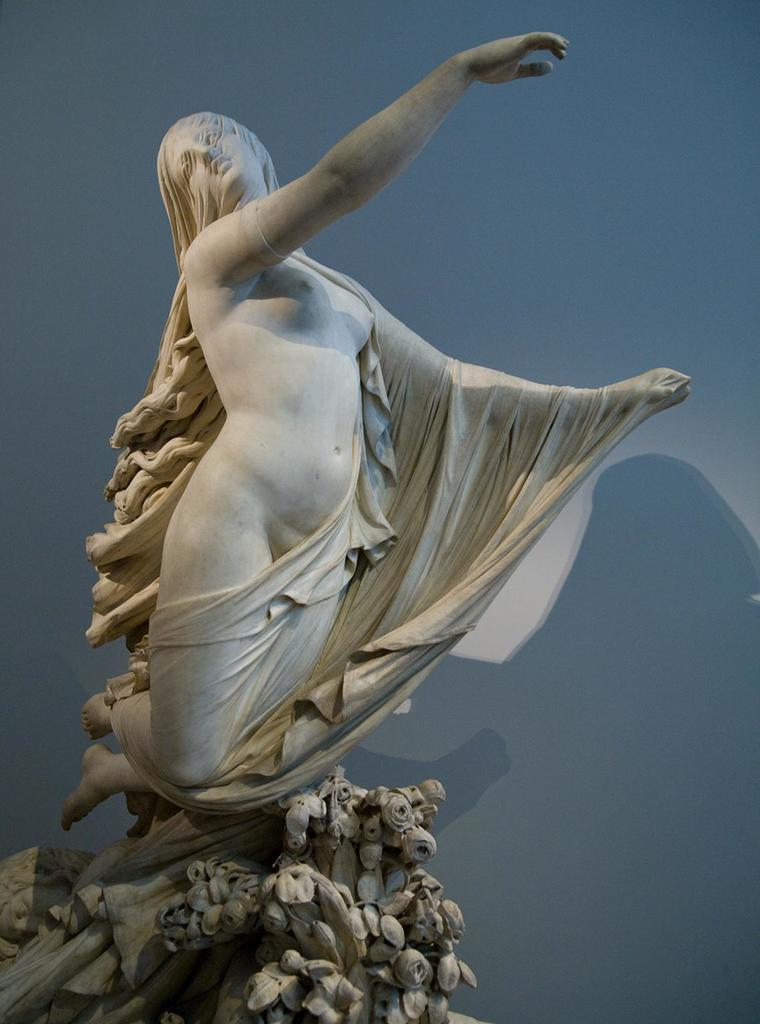What is the main subject in the foreground of the image? There is a sculpture in the foreground of the image. What can be seen in the background of the image? There is a wall in the background of the image. Can you describe any additional elements in the image? Yes, there is a shadow visible in the image. What type of error can be seen in the image? There is no error present in the image; it is a sculpture, wall, and shadow. 